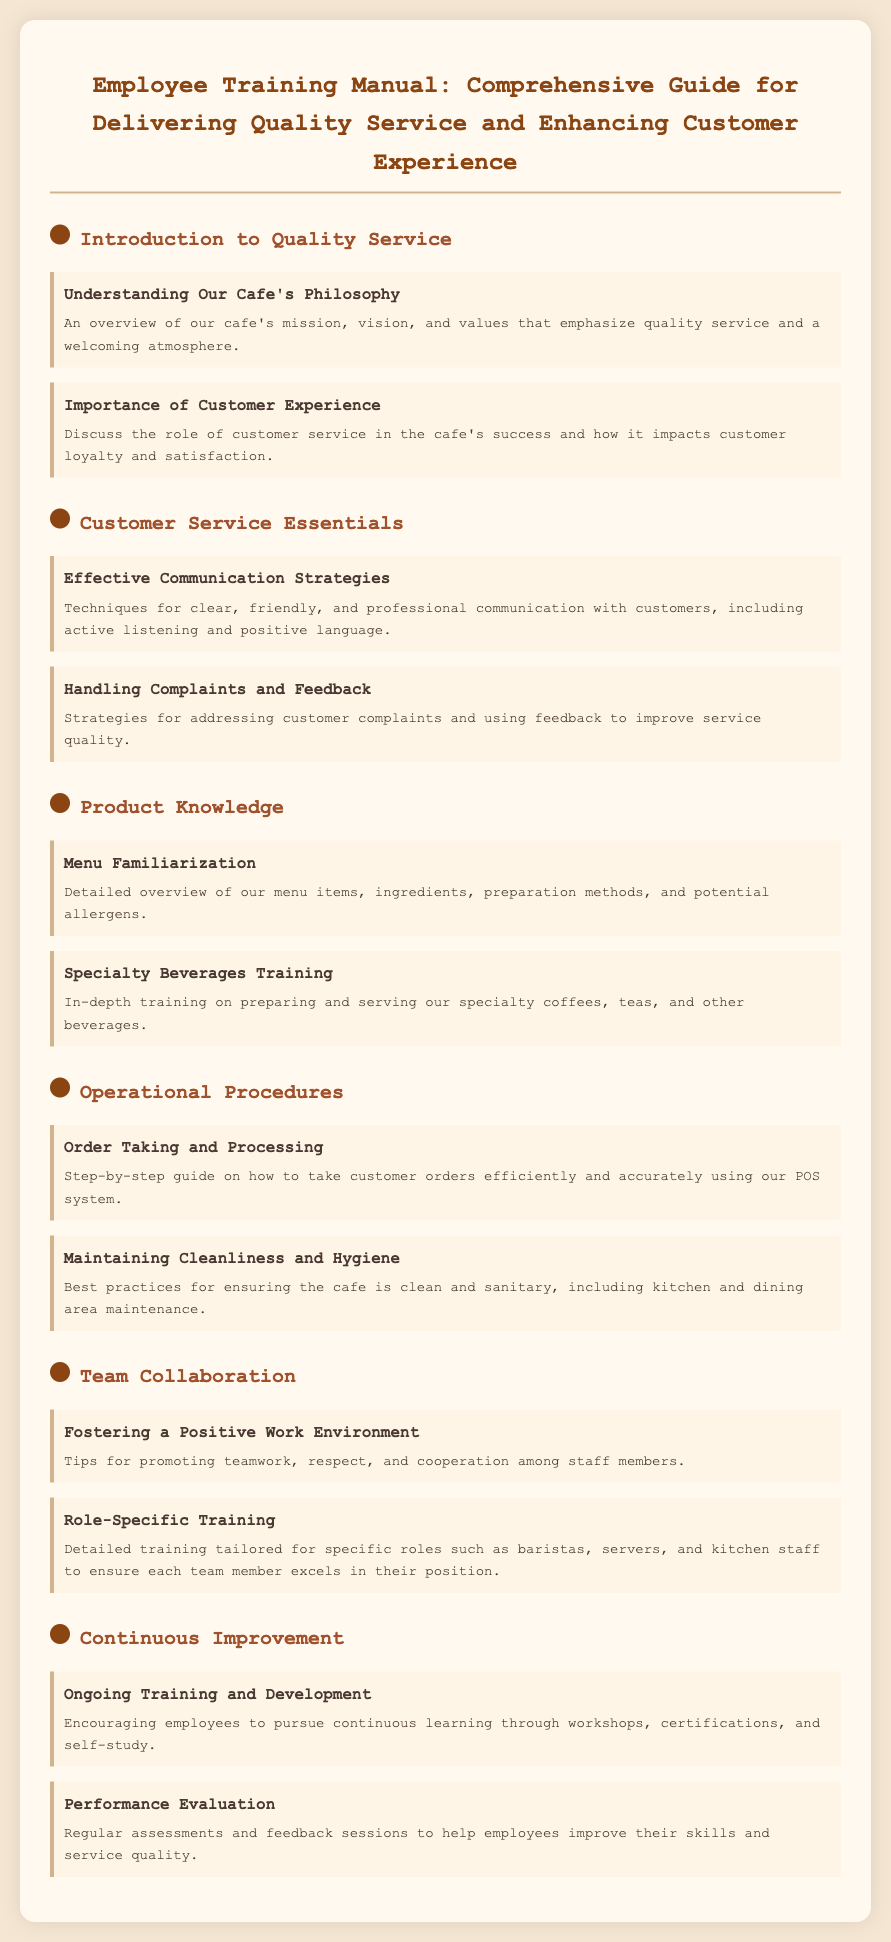what is the title of the document? The title is clearly stated at the beginning of the document.
Answer: Employee Training Manual: Comprehensive Guide for Delivering Quality Service and Enhancing Customer Experience how many sections are in the document? The document is divided into distinct sections that are listed under headings.
Answer: 6 what does the first module in the Customer Service Essentials section focus on? The first module within that section provides specific techniques related to communication.
Answer: Effective Communication Strategies what is the main focus of the Operational Procedures section? This section includes key operational details necessary for running the cafe effectively.
Answer: Order Taking and Processing which module discusses handling complaints? The module title specifies the aspect of customer complaints in relation to service.
Answer: Handling Complaints and Feedback what training is emphasized in the Product Knowledge section? The section highlights the importance of knowing menu items and beverage preparation.
Answer: Specialty Beverages Training how does the Continuous Improvement section support employees? The contents focus on methods for personal and professional development for staff.
Answer: Ongoing Training and Development what key aspect is discussed in the Team Collaboration section? This part of the document outlines ways to enhance teamwork among staff.
Answer: Fostering a Positive Work Environment describe the overall mission of the cafe as presented in the document. The document mentions a commitment to a specific customer focus.
Answer: Quality service and a welcoming atmosphere 